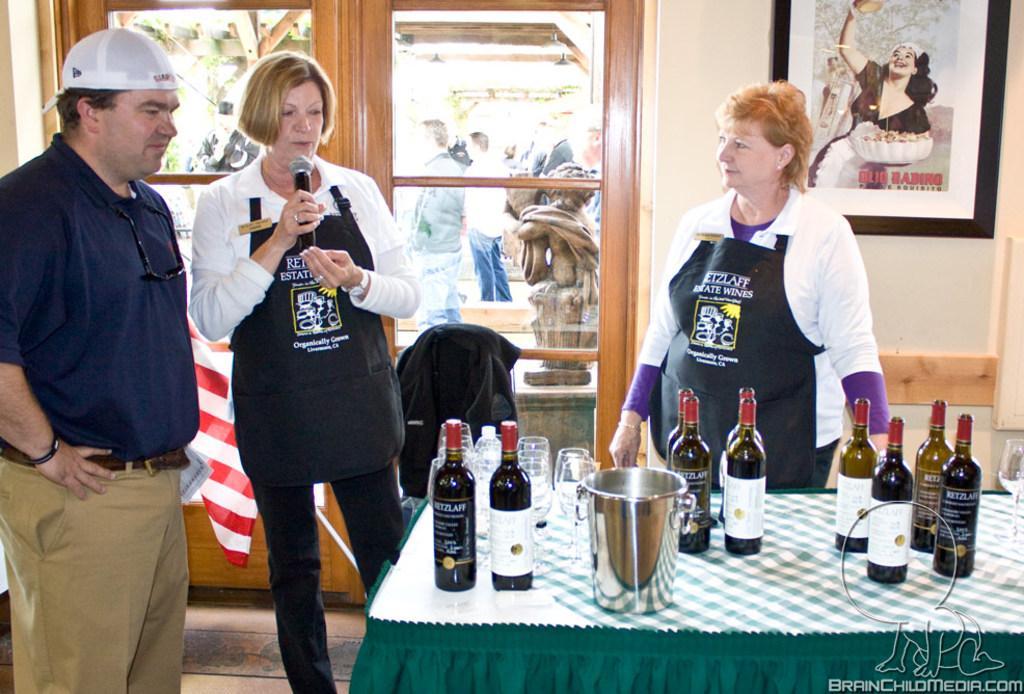Can you describe this image briefly? In this image, we can see few people. At the bottom there is a table with cloth on the floor. So many bottles, wine glasses, bucket are placed on it. Right side bottom, we can see a watermark in the image. Here we can see a woman is holding a microphone and talking. On the left side, a man is wearing a cap and smiling. Background we can see a wall, photo frame, glass doors. Through the glass door we can see the outside view. Here there is a sculpture and few people are standing. 